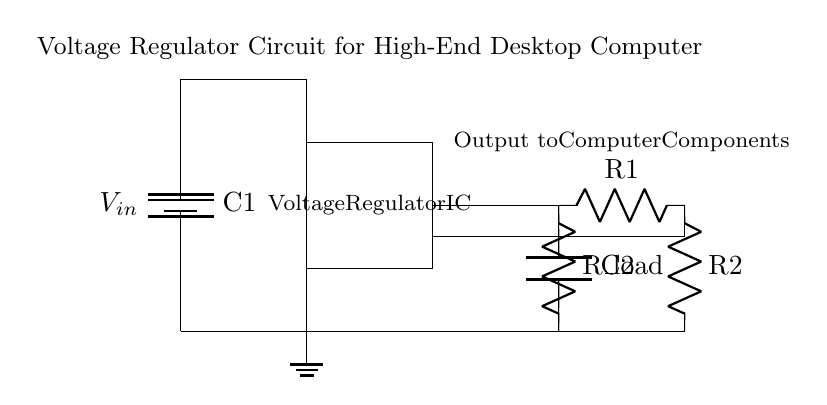What is the input voltage labeled in the circuit? The input voltage is labeled as V_in, indicating the voltage supplied to the circuit from the power source.
Answer: V_in What component stabilizes the voltage output? The component responsible for stabilizing the voltage output is the Voltage Regulator IC, which regulates the output voltage to ensure it remains constant despite variations in input voltage.
Answer: Voltage Regulator IC Which component represents the load in this circuit? The load in this circuit is represented by the R_load resistor, which symbolizes the components of the desktop computer that consume power.
Answer: R_load What are the two capacitors used for in this circuit? The two capacitors C1 and C2 serve critical functions: C1 filters noise and stabilizes the input voltage, while C2 smoothes the output voltage and absorbs fluctuations, ensuring a steady supply to the load.
Answer: C1 and C2 What is the function of the feedback resistors R1 and R2? The feedback resistors R1 and R2 are used to set and stabilize the output voltage by forming a voltage divider, feeding a portion of the output voltage back to the regulator, allowing it to adjust and maintain the desired output level.
Answer: Voltage divider How is the output voltage taken from the circuit? The output voltage is taken from the connection just after the Voltage Regulator IC; it passes through C2 and then connects to the load, providing a regulated voltage supply.
Answer: From the output connection after the Voltage Regulator IC 